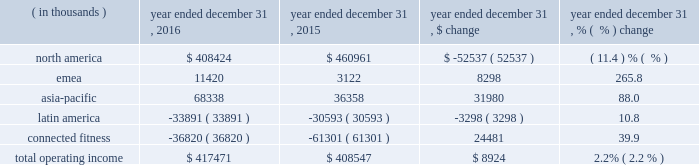Operating income ( loss ) by segment is summarized below: .
The increase in total operating income was driven by the following : 2022 operating income in our north america operating segment decreased $ 52.5 million to $ 408.4 million in 2016 from $ 461.0 million in 2015 primarily due to decreases in gross margin discussed above in the consolidated results of operations and $ 17.0 million in expenses related to the liquidation of the sports authority , comprised of $ 15.2 million in bad debt expense and $ 1.8 million of in-store fixture impairment .
In addition , this decrease reflects the movement of $ 11.1 million in expenses resulting from a strategic shift in headcount supporting our global business from our connected fitness operating segment to north america .
This decrease is partially offset by the increases in revenue discussed above in the consolidated results of operations .
2022 operating income in our emea operating segment increased $ 8.3 million to $ 11.4 million in 2016 from $ 3.1 million in 2015 primarily due to sales growth discussed above and reductions in incentive compensation .
This increase was offset by investments in sports marketing and infrastructure for future growth .
2022 operating income in our asia-pacific operating segment increased $ 31.9 million to $ 68.3 million in 2016 from $ 36.4 million in 2015 primarily due to sales growth discussed above and reductions in incentive compensation .
This increase was offset by investments in our direct-to-consumer business and entry into new territories .
2022 operating loss in our latin america operating segment increased $ 3.3 million to $ 33.9 million in 2016 from $ 30.6 million in 2015 primarily due to increased investments to support growth in the region and the economic challenges in brazil during the period .
This increase in operating loss was offset by sales growth discussed above and reductions in incentive compensation .
2022 operating loss in our connected fitness segment decreased $ 24.5 million to $ 36.8 million in 2016 from $ 61.3 million in 2015 primarily driven by sales growth discussed above .
Seasonality historically , we have recognized a majority of our net revenues and a significant portion of our income from operations in the last two quarters of the year , driven primarily by increased sales volume of our products during the fall selling season , including our higher priced cold weather products , along with a larger proportion of higher margin direct to consumer sales .
The level of our working capital generally reflects the seasonality and growth in our business .
We generally expect inventory , accounts payable and certain accrued expenses to be higher in the second and third quarters in preparation for the fall selling season. .
What portion of total operating income is generated by north america segment in 2016? 
Computations: (408424 / 417471)
Answer: 0.97833. 